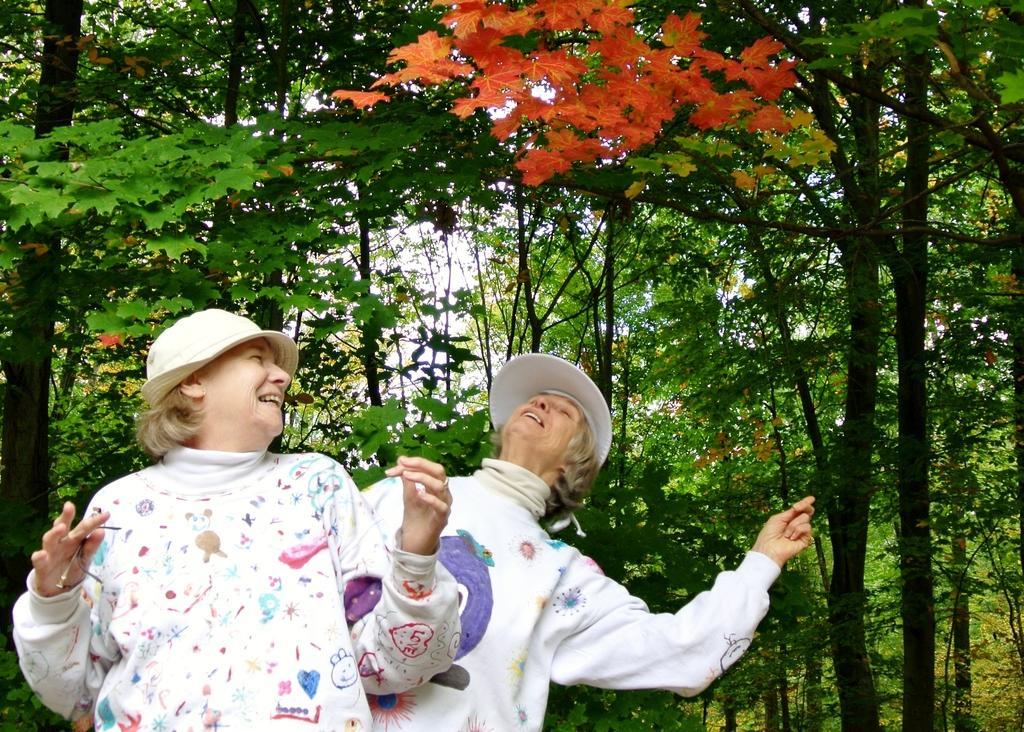Please provide a concise description of this image. In this image we can see two people wearing caps are standing. In the background, we can see a group of trees and the sky. 